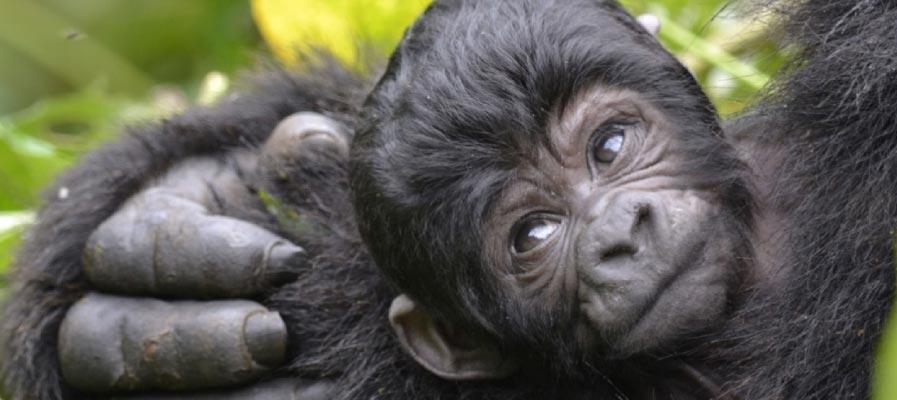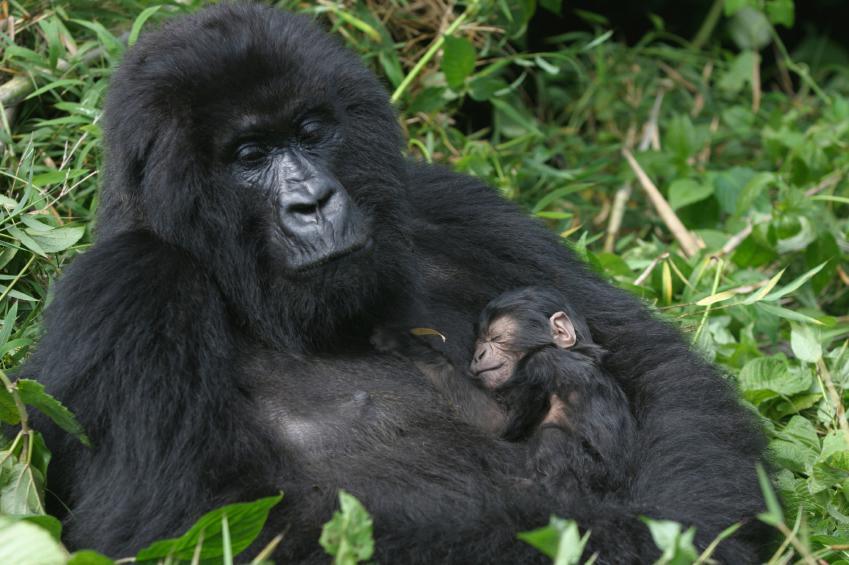The first image is the image on the left, the second image is the image on the right. Given the left and right images, does the statement "At least one baby gorilla is cuddled up with it's mother." hold true? Answer yes or no. Yes. The first image is the image on the left, the second image is the image on the right. Assess this claim about the two images: "Right image shows a young gorilla held on the chest of an adult gorilla, surrounded by foliage.". Correct or not? Answer yes or no. Yes. 